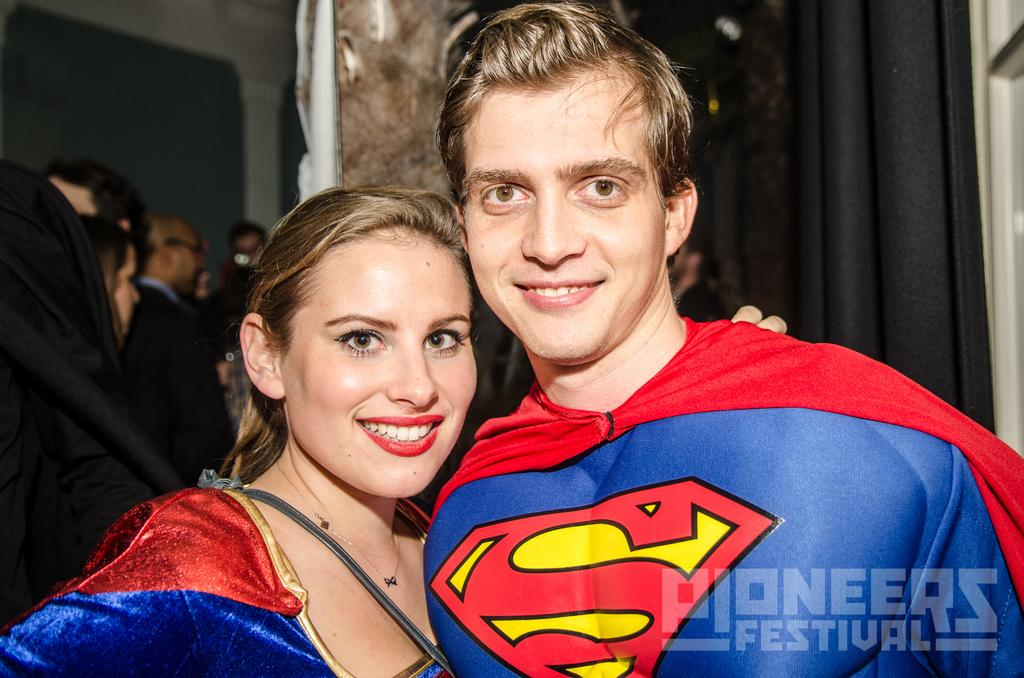What are the two people in the foreground of the image wearing? The two people in the foreground of the image are wearing costumes. What can be seen in the background of the image? In the background of the image, there are additional people with dresses and black color curtains. There is also a wall visible. How many people with costumes are in the image? There are two people with costumes in the foreground of the image. What type of boat is present in the image? There is no boat present in the image. What error can be seen in the costumes of the two people in the foreground? There is no error mentioned in the costumes of the two people in the foreground; they appear to be wearing their costumes correctly. 